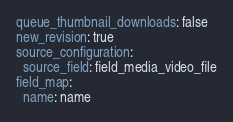Convert code to text. <code><loc_0><loc_0><loc_500><loc_500><_YAML_>queue_thumbnail_downloads: false
new_revision: true
source_configuration:
  source_field: field_media_video_file
field_map:
  name: name
</code> 